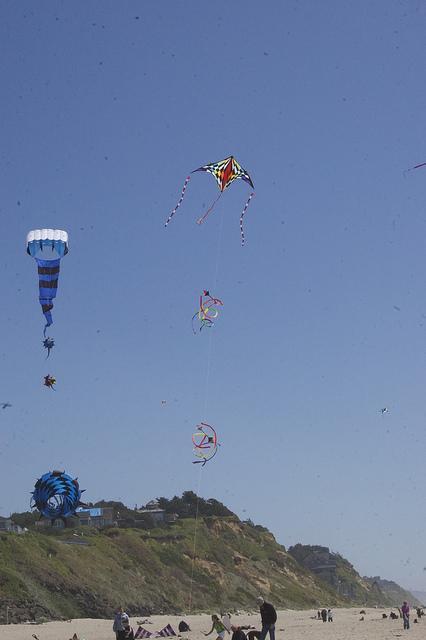How many hot air balloons can be found in the picture?
Give a very brief answer. 0. 